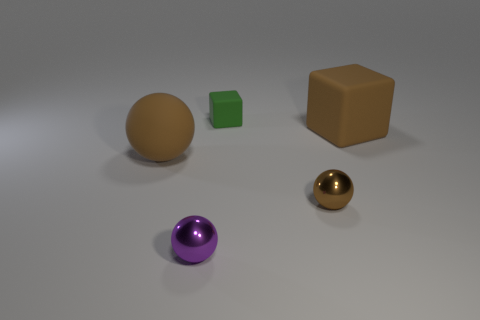Subtract all tiny shiny balls. How many balls are left? 1 Subtract all purple spheres. How many spheres are left? 2 Subtract all cubes. How many objects are left? 3 Add 1 large brown metal things. How many objects exist? 6 Add 1 large brown matte cubes. How many large brown matte cubes exist? 2 Subtract 1 brown cubes. How many objects are left? 4 Subtract 1 blocks. How many blocks are left? 1 Subtract all yellow spheres. Subtract all yellow blocks. How many spheres are left? 3 Subtract all cyan balls. How many green cubes are left? 1 Subtract all big gray shiny spheres. Subtract all brown blocks. How many objects are left? 4 